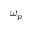<formula> <loc_0><loc_0><loc_500><loc_500>\omega _ { p }</formula> 